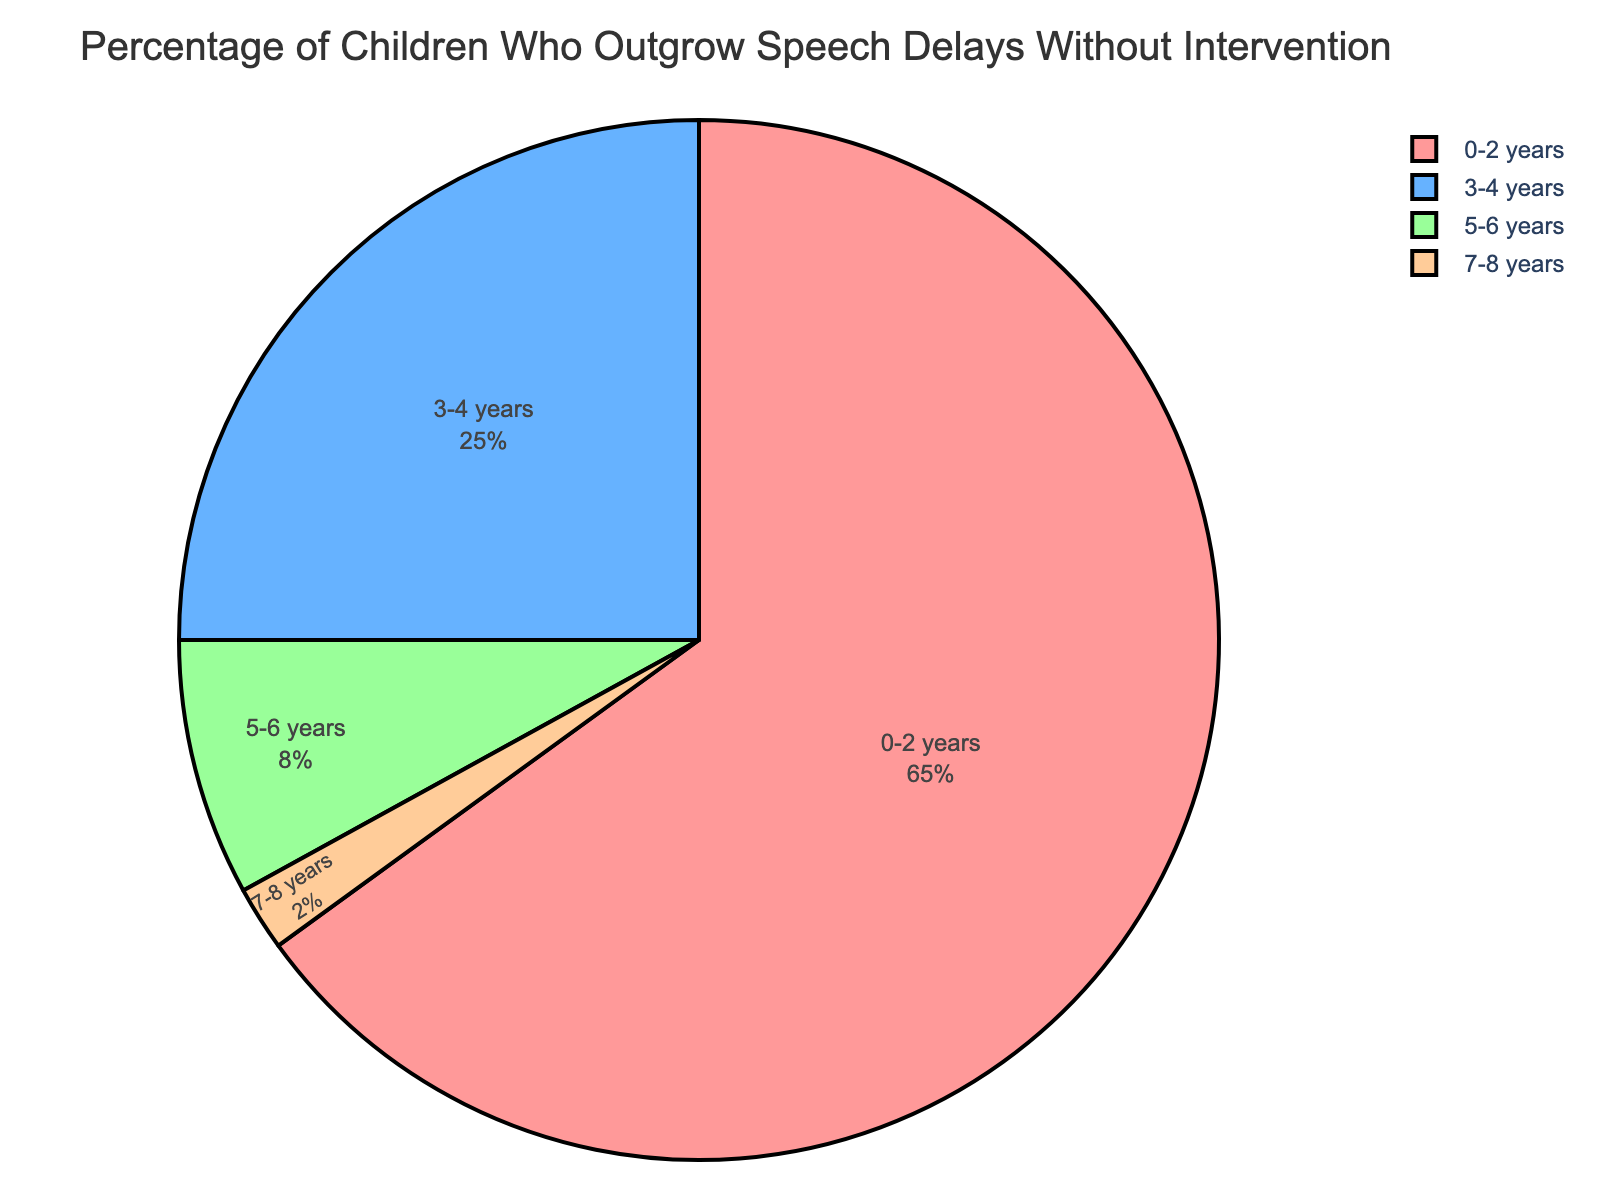What age group has the highest percentage of children who outgrow speech delays without intervention? According to the pie chart, the age group with the highest percentage of children who outgrow speech delays without intervention is 0-2 years, which accounts for 65%
Answer: 0-2 years Which age group has a lower percentage of children who outgrow speech delays without intervention: 3-4 years or 5-6 years? By comparing the slices of the pie chart, the age group 5-6 years has a lower percentage (8%) compared to 3-4 years (25%)
Answer: 5-6 years What is the combined percentage of children who outgrow speech delays without intervention in the 5-6 years and 7-8 years age groups? To find the combined percentage, add the percentages of the 5-6 years (8%) and 7-8 years (2%) age groups: 8% + 2%
Answer: 10% How does the percentage of children who outgrow speech delays without intervention in the 0-2 years age group compare to the other age groups combined? The combined percentage of the 3-4 years, 5-6 years, and 7-8 years age groups is 25% + 8% + 2% = 35%. The 0-2 years age group has 65%, which is higher than the 35% of the other age groups combined
Answer: Higher What is the percentage difference between the 3-4 years and 7-8 years age groups in children who outgrow speech delays without intervention? Subtract the percentage of the 7-8 years age group (2%) from the 3-4 years age group (25%): 25% - 2%
Answer: 23% Which age group has the smallest portion in the pie chart? The age group with the smallest portion in the pie chart is 7-8 years, with a percentage of 2%
Answer: 7-8 years If you focus on the colors of the pie chart, which age group is represented by the green slice? The green slice in the pie chart represents the 5-6 years age group
Answer: 5-6 years What is the sum of the percentages of the age groups 3-4 years and 7-8 years? Add the percentages of the 3-4 years (25%) and 7-8 years (2%) age groups: 25% + 2%
Answer: 27% Which two age groups combined make up more than half of the pie chart? The age group 0-2 years is 65%, which is already more than half. Therefore, the combination of 0-2 years with any other age group will still be more than half. But the valid pair is 0-2 years and 3-4 years (65% + 25% = 90%)
Answer: 0-2 years and 3-4 years 